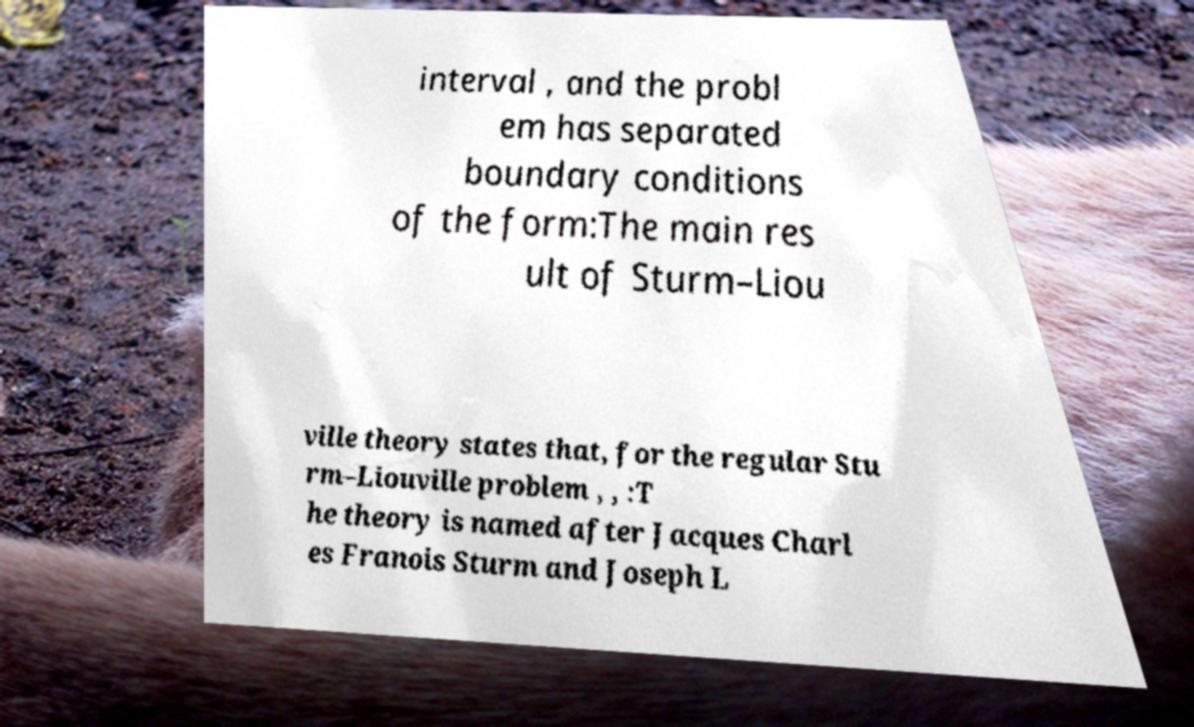For documentation purposes, I need the text within this image transcribed. Could you provide that? interval , and the probl em has separated boundary conditions of the form:The main res ult of Sturm–Liou ville theory states that, for the regular Stu rm–Liouville problem , , :T he theory is named after Jacques Charl es Franois Sturm and Joseph L 